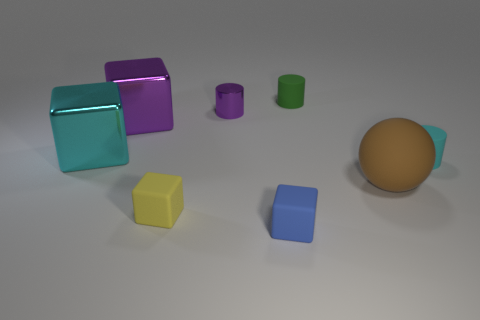What shape is the yellow object?
Keep it short and to the point. Cube. Is the brown thing the same shape as the small blue thing?
Offer a terse response. No. What is the shape of the cyan thing that is in front of the cyan thing on the left side of the yellow cube?
Offer a terse response. Cylinder. Are there any big purple matte balls?
Give a very brief answer. No. There is a rubber object behind the tiny matte object that is on the right side of the brown rubber ball; how many small shiny cylinders are right of it?
Make the answer very short. 0. There is a yellow object; does it have the same shape as the small matte object that is behind the purple metal cylinder?
Your answer should be very brief. No. Is the number of green rubber things greater than the number of large blue balls?
Make the answer very short. Yes. Is there any other thing that has the same size as the purple metallic cylinder?
Provide a succinct answer. Yes. There is a matte thing in front of the yellow rubber cube; is it the same shape as the green thing?
Your response must be concise. No. Is the number of green cylinders behind the small cyan matte cylinder greater than the number of green cylinders?
Your answer should be very brief. No. 